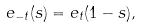<formula> <loc_0><loc_0><loc_500><loc_500>e _ { - t } ( s ) = e _ { t } ( 1 - s ) ,</formula> 